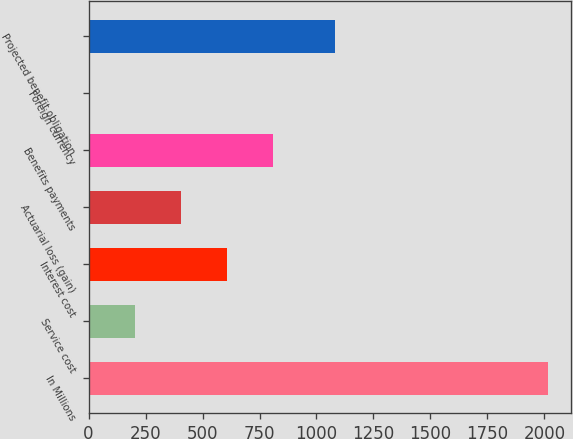<chart> <loc_0><loc_0><loc_500><loc_500><bar_chart><fcel>In Millions<fcel>Service cost<fcel>Interest cost<fcel>Actuarial loss (gain)<fcel>Benefits payments<fcel>Foreign currency<fcel>Projected benefit obligation<nl><fcel>2015<fcel>204.2<fcel>606.6<fcel>405.4<fcel>807.8<fcel>3<fcel>1079.6<nl></chart> 